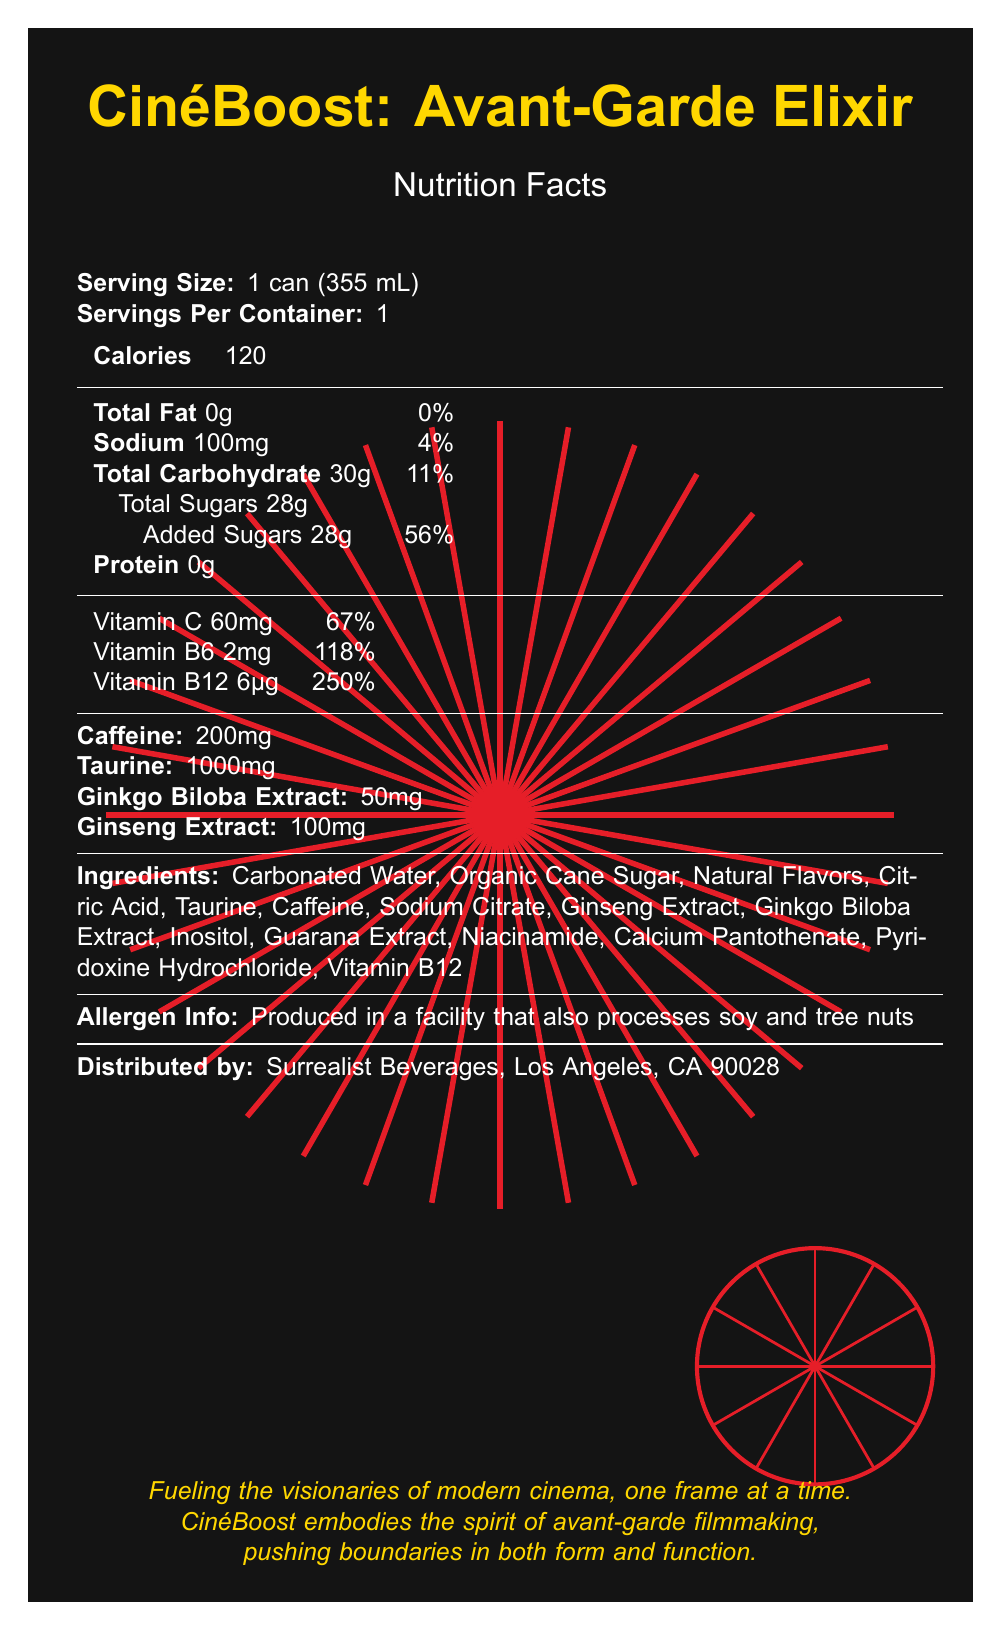how many calories are in one serving? The document states that there are 120 calories per serving.
Answer: 120 what is the daily value percentage of vitamin C? According to the document, the daily value percentage of Vitamin C is 67%.
Answer: 67% how much caffeine does CinemBoost contain? The document lists the caffeine content as 200mg.
Answer: 200mg what is the sodium content in a can? The document specifies that each can contains 100mg of sodium.
Answer: 100mg does CinéBoost contain protein? The document states that CinéBoost has 0g of protein.
Answer: No what ingredient is listed last in the ingredients list? A. Ginseng Extract B. Vitamin B12 C. Guarana Extract D. Inositol The ingredients list in the document ends with Vitamin B12.
Answer: B. Vitamin B12 how many servings are there per container? A. 1 B. 2 C. 3 D. 4 The document mentions that there is 1 serving per container.
Answer: A. 1 can someone with a tree nut allergy safely consume this product? The document indicates that CinéBoost is produced in a facility that also processes soy and tree nuts, which could pose a risk for someone with a tree nut allergy.
Answer: No is there any information about the manufacturing date on the label? The document does not provide any details regarding the manufacturing date.
Answer: Not enough information what is the primary purpose of the graphic elements in the design of the CinéBoost label? The document mentions that the graphic elements are inspired by avant-garde film techniques and cinema-related imagery.
Answer: To represent cinema and avant-garde filmmaking describe the overall branding and purpose of CinéBoost: Avant-Garde Elixir The document highlights that CinéBoost is designed for film set crews and incorporates bold, cinema-inspired graphics. It lists nutritional information, unique ingredients, and a cultural impact statement tying the product to avant-garde filmmaking.
Answer: CinéBoost: Avant-Garde Elixir is an energy drink designed for film set crews, featuring bold graphic elements inspired by avant-garde cinema. It includes a technicolor spiral, an abstract camera lens iris, and geometric patterns. The beverage is targeted towards filmmakers and aims to fuel their creativity and hard work on film sets. The label emphasizes its unique nutrients and cultural impact on modern cinema. 